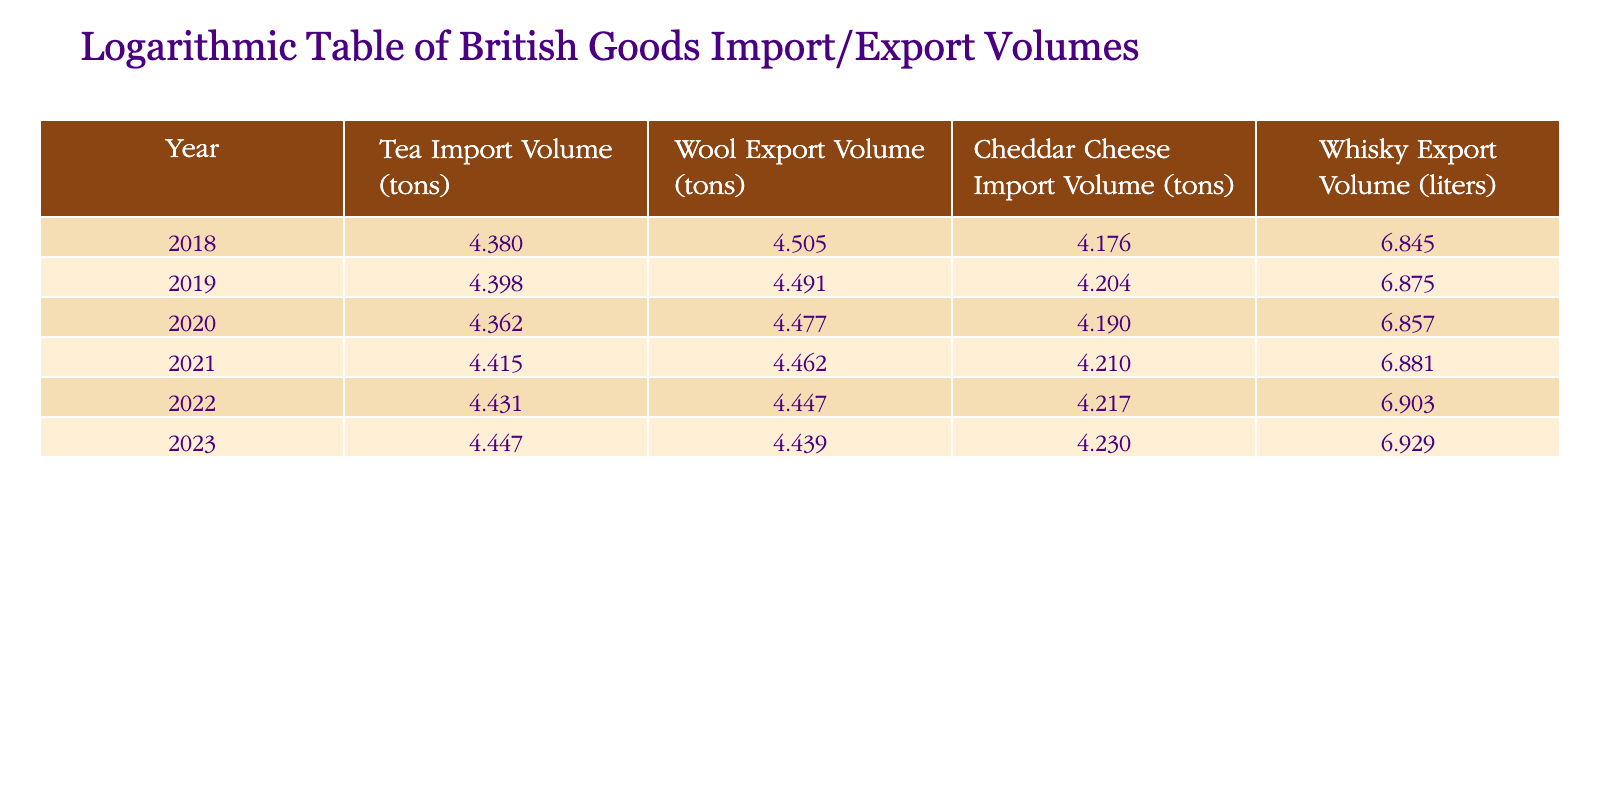What was the tea import volume in 2023? Looking at the table for the year 2023, the tea import volume is listed as 28000 tons.
Answer: 28000 tons What is the wool export volume for the year 2020? Checking the table for the year 2020, the wool export volume is noted as 30000 tons.
Answer: 30000 tons Is the cheddar cheese import volume higher in 2022 than in 2019? In 2022, the cheddar cheese import volume is 16500 tons, while in 2019 it is 16000 tons. Since 16500 is greater than 16000, the statement is true.
Answer: Yes What was the total whisky export volume from 2018 to 2023? To find the total whisky export volume, we sum the values from each year: 7000000 + 7500000 + 7200000 + 7600000 + 8000000 + 8500000 = 45800000 liters.
Answer: 45800000 liters What is the average wool export volume over the years shown? The wool export volumes for each year are: 32000, 31000, 30000, 29000, 28000, and 27500. The total is 178000 tons. Dividing this by 6 (the number of years) gives an average of 29666.67 tons.
Answer: 29666.67 tons Did the tea import volume decrease from 2019 to 2020? In 2019, the tea import volume is 25000 tons, while in 2020 it decreased to 23000 tons. Therefore, the statement is true.
Answer: Yes What was the percentage increase in whisky export volume from 2018 to 2023? The whisky export volume increased from 7000000 liters in 2018 to 8500000 liters in 2023. The increase is 8500000 - 7000000 = 1500000 liters. The percentage increase is (1500000 / 7000000) * 100 = approximately 21.43%.
Answer: 21.43% Which year had the highest cheddar cheese import volume? By examining the cheddar cheese import volumes listed, 2023 has the highest volume at 17000 tons compared to the other years.
Answer: 2023 What was the difference in tea import volume between 2021 and 2022? The tea import volume in 2021 is 26000 tons and in 2022 is 27000 tons. The difference is 27000 - 26000 = 1000 tons.
Answer: 1000 tons 